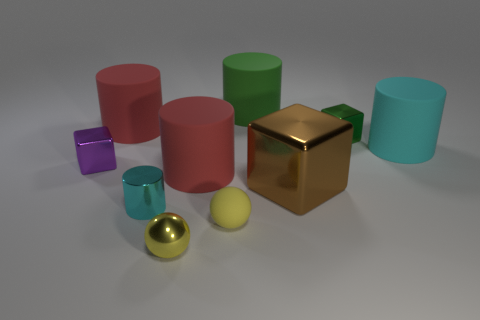There is a matte object that is in front of the small cyan cylinder; is it the same color as the shiny sphere?
Ensure brevity in your answer.  Yes. How many things are big brown rubber cylinders or big rubber cylinders on the left side of the big metal block?
Provide a succinct answer. 3. Are there more red cylinders behind the tiny green cube than small purple blocks that are in front of the yellow shiny ball?
Offer a terse response. Yes. What material is the big cylinder behind the red matte cylinder that is behind the cyan thing that is on the right side of the green cylinder?
Make the answer very short. Rubber. What shape is the brown thing that is the same material as the small purple object?
Offer a very short reply. Cube. There is a large red cylinder in front of the large cyan rubber cylinder; are there any large red cylinders that are in front of it?
Provide a succinct answer. No. How big is the cyan matte object?
Ensure brevity in your answer.  Large. What number of objects are cylinders or green metallic cubes?
Give a very brief answer. 6. Does the cyan object that is to the right of the brown block have the same material as the big red cylinder that is on the right side of the small yellow metal ball?
Ensure brevity in your answer.  Yes. What is the color of the small ball that is the same material as the purple object?
Your answer should be compact. Yellow. 